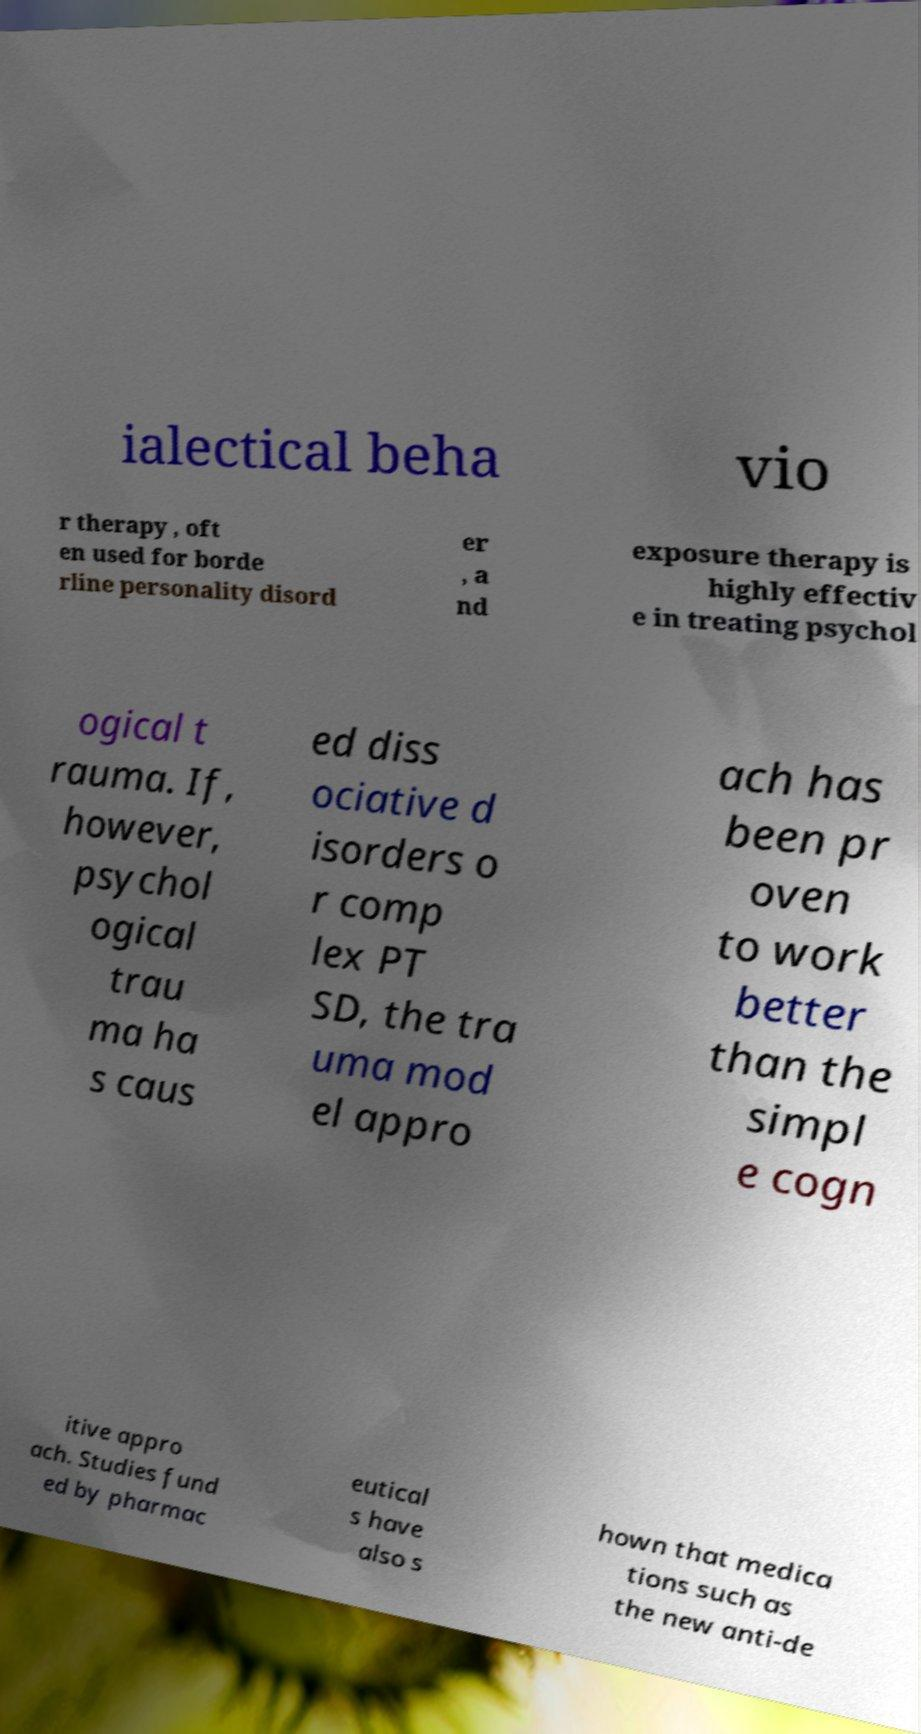Please identify and transcribe the text found in this image. ialectical beha vio r therapy , oft en used for borde rline personality disord er , a nd exposure therapy is highly effectiv e in treating psychol ogical t rauma. If, however, psychol ogical trau ma ha s caus ed diss ociative d isorders o r comp lex PT SD, the tra uma mod el appro ach has been pr oven to work better than the simpl e cogn itive appro ach. Studies fund ed by pharmac eutical s have also s hown that medica tions such as the new anti-de 